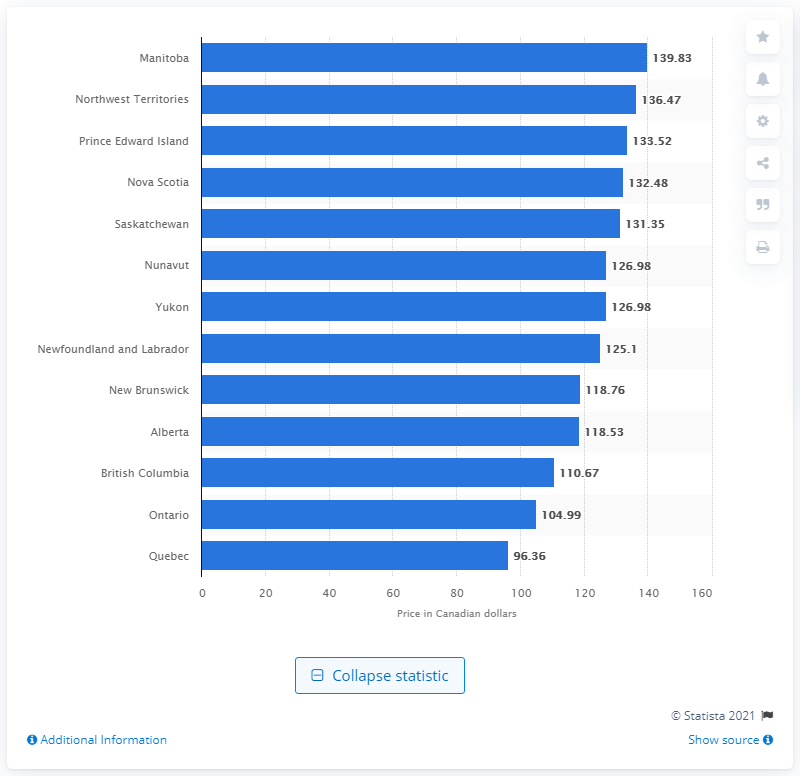Outline some significant characteristics in this image. In March 2018, the average Canadian paid $139.83 for a pack of 200 cigarettes. The cheapest carton of cigarettes in Quebec was 96.36. 